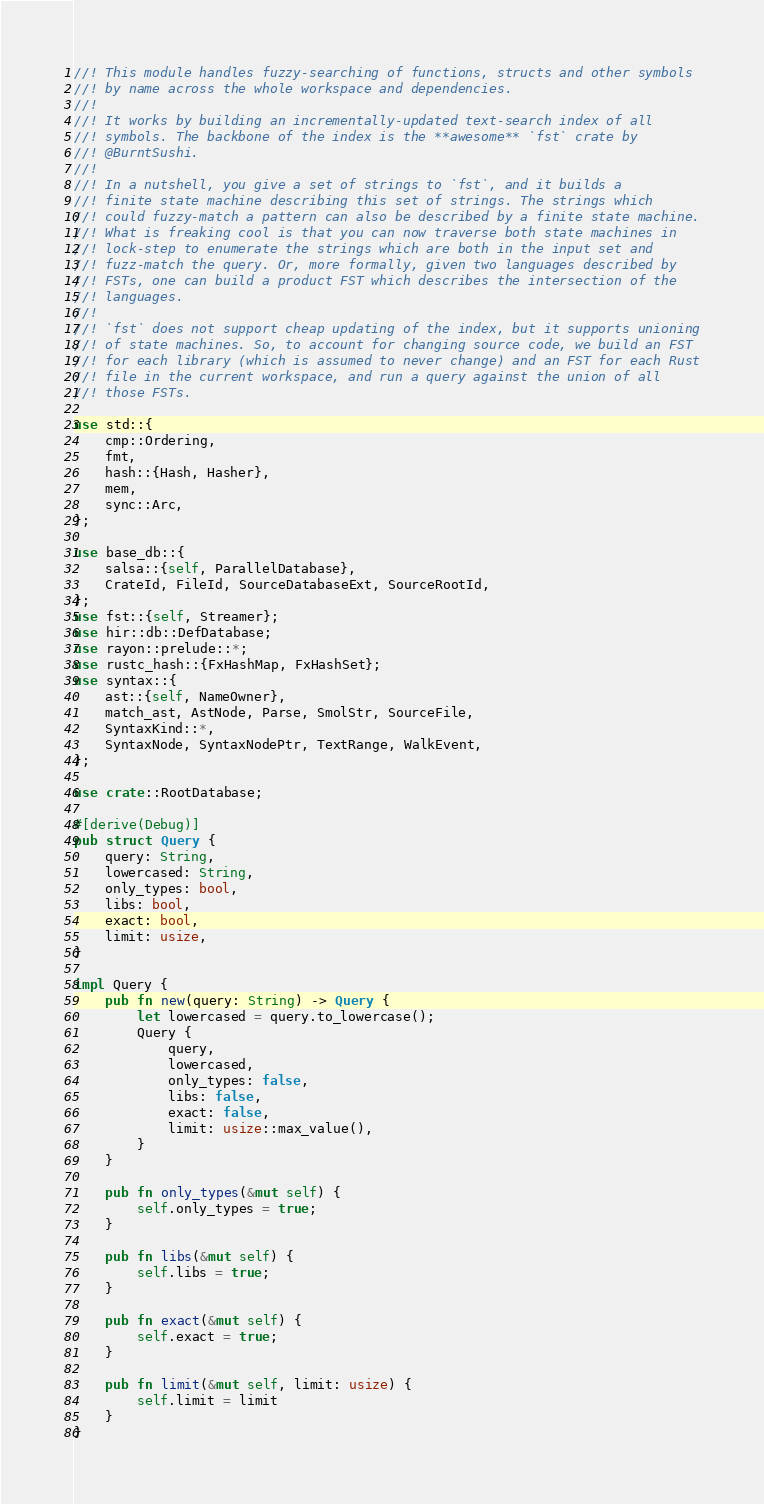<code> <loc_0><loc_0><loc_500><loc_500><_Rust_>//! This module handles fuzzy-searching of functions, structs and other symbols
//! by name across the whole workspace and dependencies.
//!
//! It works by building an incrementally-updated text-search index of all
//! symbols. The backbone of the index is the **awesome** `fst` crate by
//! @BurntSushi.
//!
//! In a nutshell, you give a set of strings to `fst`, and it builds a
//! finite state machine describing this set of strings. The strings which
//! could fuzzy-match a pattern can also be described by a finite state machine.
//! What is freaking cool is that you can now traverse both state machines in
//! lock-step to enumerate the strings which are both in the input set and
//! fuzz-match the query. Or, more formally, given two languages described by
//! FSTs, one can build a product FST which describes the intersection of the
//! languages.
//!
//! `fst` does not support cheap updating of the index, but it supports unioning
//! of state machines. So, to account for changing source code, we build an FST
//! for each library (which is assumed to never change) and an FST for each Rust
//! file in the current workspace, and run a query against the union of all
//! those FSTs.

use std::{
    cmp::Ordering,
    fmt,
    hash::{Hash, Hasher},
    mem,
    sync::Arc,
};

use base_db::{
    salsa::{self, ParallelDatabase},
    CrateId, FileId, SourceDatabaseExt, SourceRootId,
};
use fst::{self, Streamer};
use hir::db::DefDatabase;
use rayon::prelude::*;
use rustc_hash::{FxHashMap, FxHashSet};
use syntax::{
    ast::{self, NameOwner},
    match_ast, AstNode, Parse, SmolStr, SourceFile,
    SyntaxKind::*,
    SyntaxNode, SyntaxNodePtr, TextRange, WalkEvent,
};

use crate::RootDatabase;

#[derive(Debug)]
pub struct Query {
    query: String,
    lowercased: String,
    only_types: bool,
    libs: bool,
    exact: bool,
    limit: usize,
}

impl Query {
    pub fn new(query: String) -> Query {
        let lowercased = query.to_lowercase();
        Query {
            query,
            lowercased,
            only_types: false,
            libs: false,
            exact: false,
            limit: usize::max_value(),
        }
    }

    pub fn only_types(&mut self) {
        self.only_types = true;
    }

    pub fn libs(&mut self) {
        self.libs = true;
    }

    pub fn exact(&mut self) {
        self.exact = true;
    }

    pub fn limit(&mut self, limit: usize) {
        self.limit = limit
    }
}
</code> 